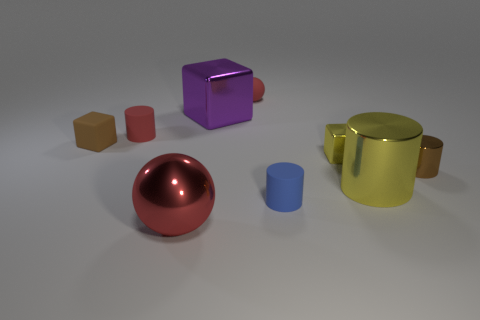There is a blue cylinder; are there any yellow shiny blocks left of it?
Offer a very short reply. No. What number of tiny metallic things are the same shape as the large purple thing?
Offer a very short reply. 1. Is the material of the purple block the same as the small block that is to the right of the blue rubber cylinder?
Provide a short and direct response. Yes. What number of gray metal things are there?
Offer a very short reply. 0. How big is the metallic cylinder in front of the brown metal cylinder?
Make the answer very short. Large. How many brown rubber cubes are the same size as the brown metallic cylinder?
Offer a very short reply. 1. The thing that is both to the left of the matte sphere and in front of the big yellow object is made of what material?
Your answer should be very brief. Metal. There is a yellow block that is the same size as the brown cube; what material is it?
Provide a succinct answer. Metal. There is a matte cylinder behind the tiny shiny object that is left of the brown thing on the right side of the big purple shiny cube; how big is it?
Keep it short and to the point. Small. There is a brown thing that is made of the same material as the big purple block; what size is it?
Ensure brevity in your answer.  Small. 